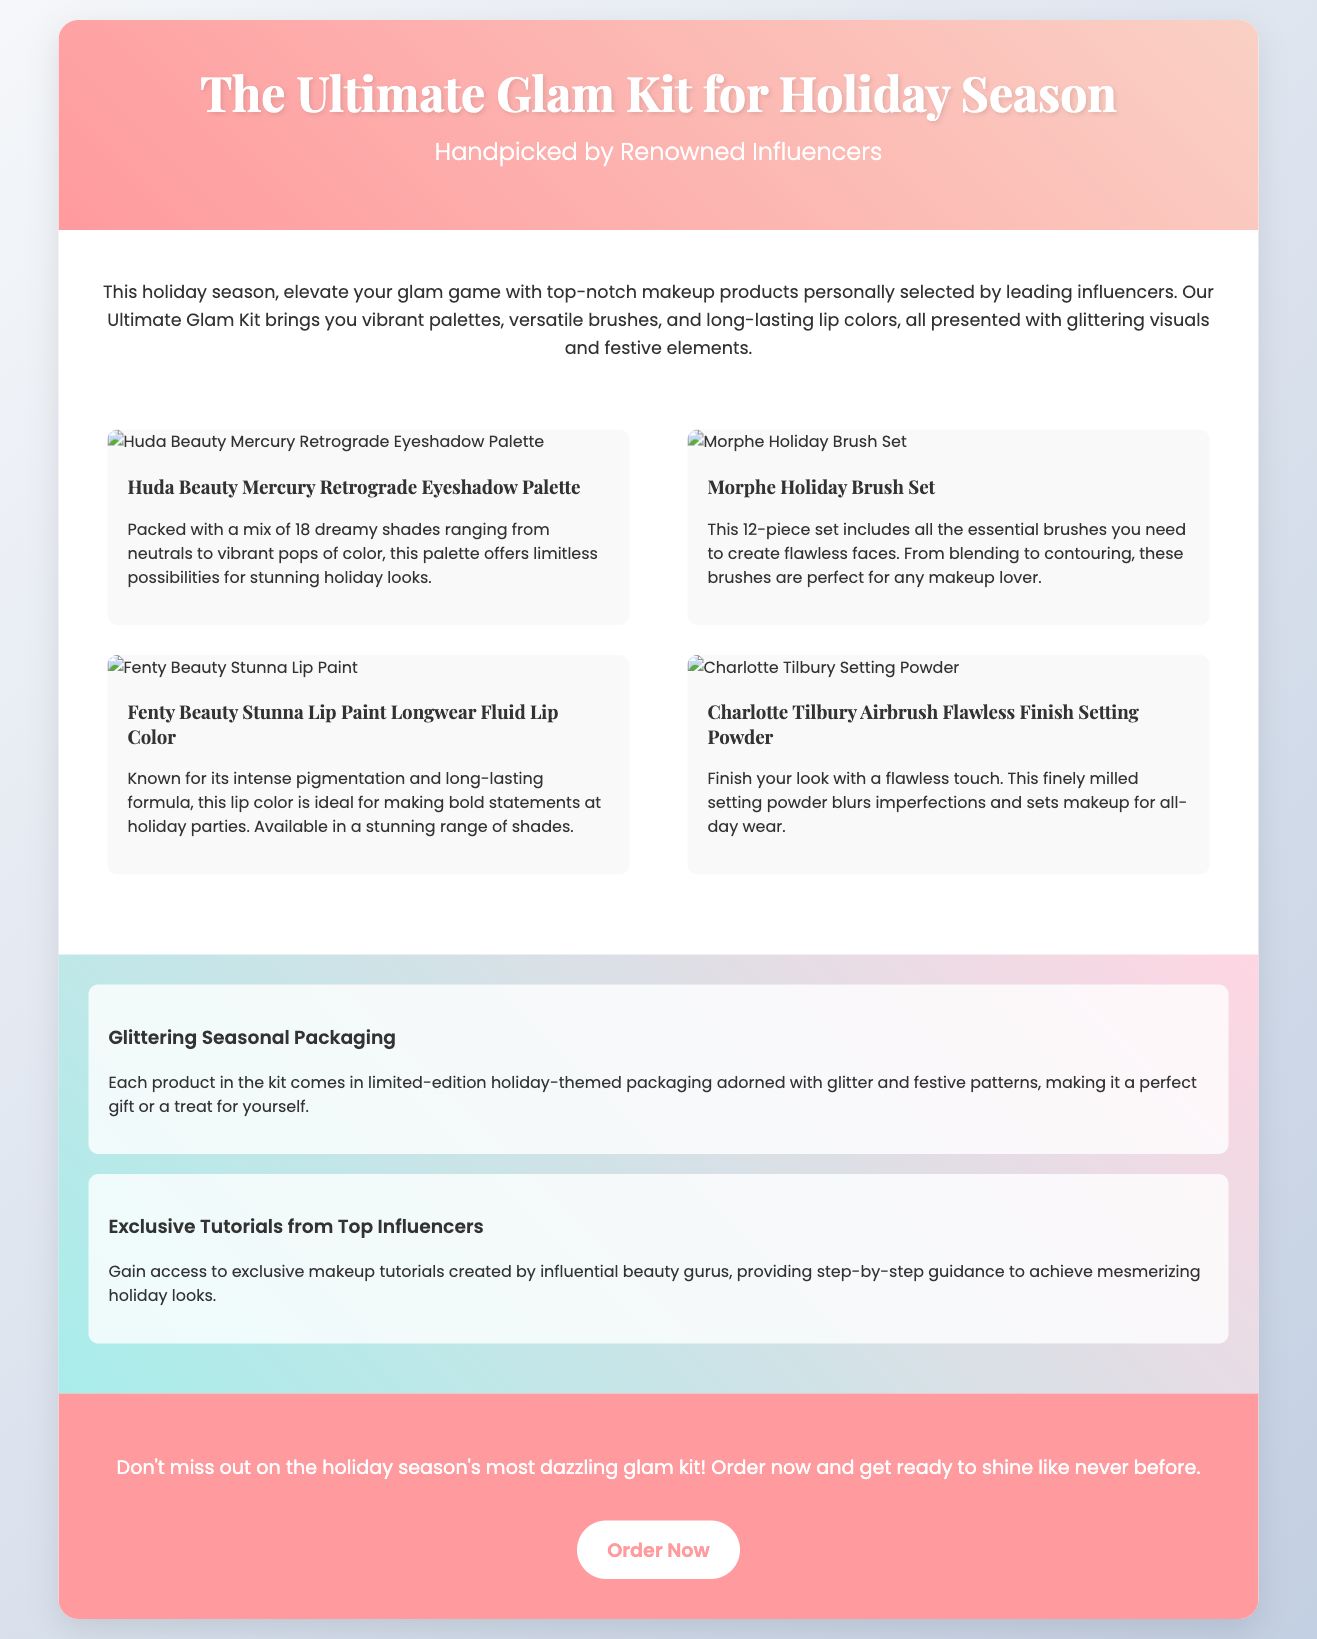What is the title of the kit? The title is found in the header section of the document and states the product name clearly.
Answer: The Ultimate Glam Kit for Holiday Season Who handpicked the products? The introduction mentions that the products are selected by influential figures in the beauty industry.
Answer: Renowned Influencers How many products are featured in the kit? The products section lists a total of four different makeup items included in the kit.
Answer: Four What type of packaging do the products have? The features section describes the packaging of the kit, emphasizing its seasonal design for the holidays.
Answer: Glittering Seasonal Packaging What is the main color of the call-to-action button? The styling of the button is highlighted in the document, which makes it visually distinct.
Answer: White What type of tutorials are offered with the kit? The features section indicates what kind of additional resources come with the kit.
Answer: Exclusive Tutorials from Top Influencers Which product provides long-lasting lip color? The product description provides specific information on the lip color included in the kit.
Answer: Fenty Beauty Stunna Lip Paint Longwear Fluid Lip Color What is the purpose of the setting powder? The product description explains the function of the setting powder included in the kit.
Answer: Blurs imperfections and sets makeup What is the main theme of the advertisement? The introduction elaborates on the overall theme aimed for the holiday season.
Answer: Festive elements 